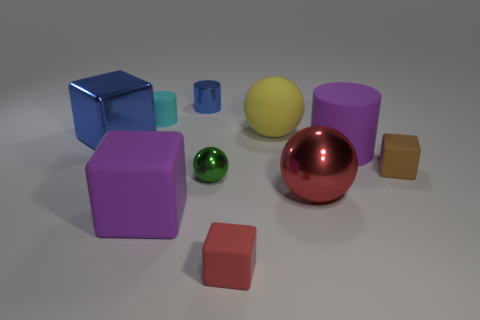Subtract all blocks. How many objects are left? 6 Subtract 0 brown cylinders. How many objects are left? 10 Subtract all small red cubes. Subtract all blue metallic objects. How many objects are left? 7 Add 7 small brown objects. How many small brown objects are left? 8 Add 5 large blue balls. How many large blue balls exist? 5 